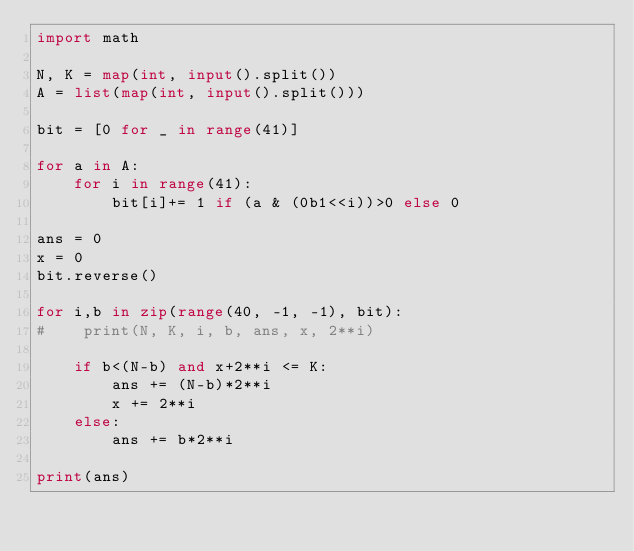Convert code to text. <code><loc_0><loc_0><loc_500><loc_500><_Python_>import math

N, K = map(int, input().split())
A = list(map(int, input().split()))

bit = [0 for _ in range(41)]

for a in A:
    for i in range(41):
        bit[i]+= 1 if (a & (0b1<<i))>0 else 0

ans = 0
x = 0
bit.reverse()

for i,b in zip(range(40, -1, -1), bit):
#    print(N, K, i, b, ans, x, 2**i)

    if b<(N-b) and x+2**i <= K:
        ans += (N-b)*2**i
        x += 2**i                        
    else:
        ans += b*2**i

print(ans)


</code> 